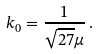Convert formula to latex. <formula><loc_0><loc_0><loc_500><loc_500>k _ { 0 } = \frac { 1 } { \sqrt { 2 7 } \mu } \, .</formula> 